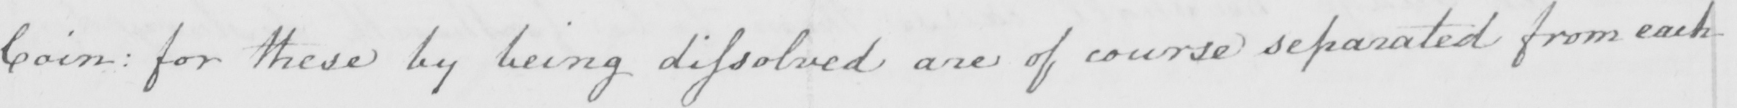Please provide the text content of this handwritten line. Coin :  for these by being dissolved are of course separated from each 